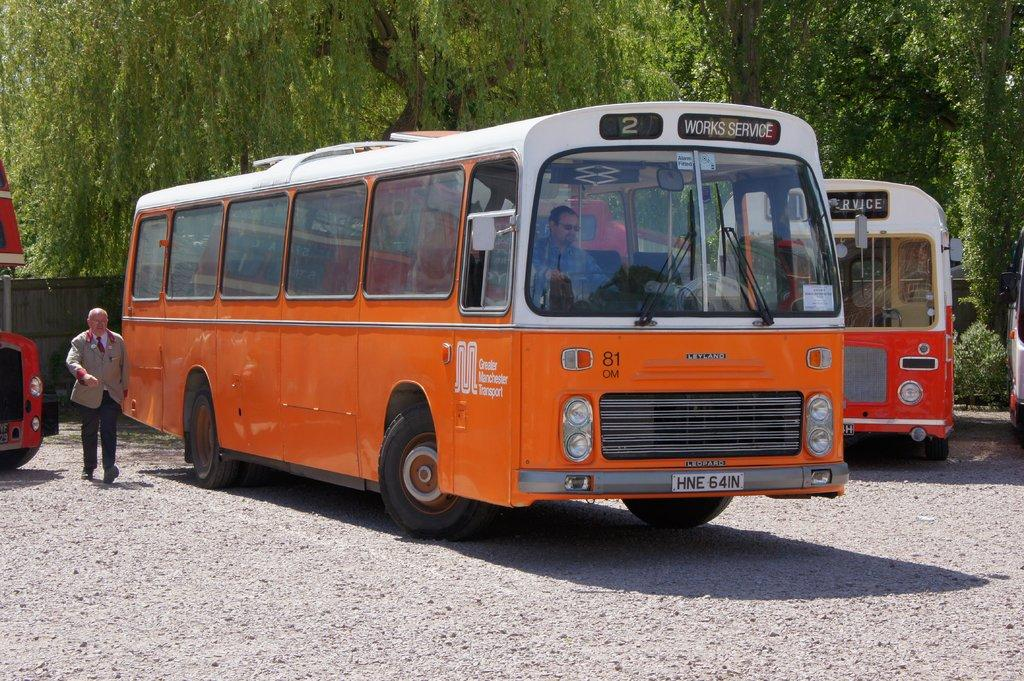Provide a one-sentence caption for the provided image. An orange bus with the sign Works Service for Greater Manchester Transport. 